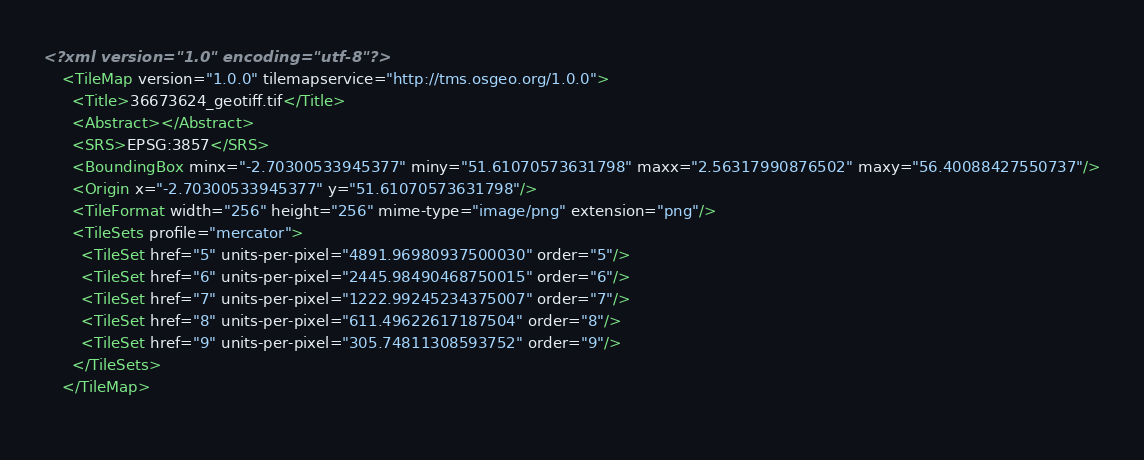<code> <loc_0><loc_0><loc_500><loc_500><_XML_><?xml version="1.0" encoding="utf-8"?>
    <TileMap version="1.0.0" tilemapservice="http://tms.osgeo.org/1.0.0">
      <Title>36673624_geotiff.tif</Title>
      <Abstract></Abstract>
      <SRS>EPSG:3857</SRS>
      <BoundingBox minx="-2.70300533945377" miny="51.61070573631798" maxx="2.56317990876502" maxy="56.40088427550737"/>
      <Origin x="-2.70300533945377" y="51.61070573631798"/>
      <TileFormat width="256" height="256" mime-type="image/png" extension="png"/>
      <TileSets profile="mercator">
        <TileSet href="5" units-per-pixel="4891.96980937500030" order="5"/>
        <TileSet href="6" units-per-pixel="2445.98490468750015" order="6"/>
        <TileSet href="7" units-per-pixel="1222.99245234375007" order="7"/>
        <TileSet href="8" units-per-pixel="611.49622617187504" order="8"/>
        <TileSet href="9" units-per-pixel="305.74811308593752" order="9"/>
      </TileSets>
    </TileMap>
    </code> 